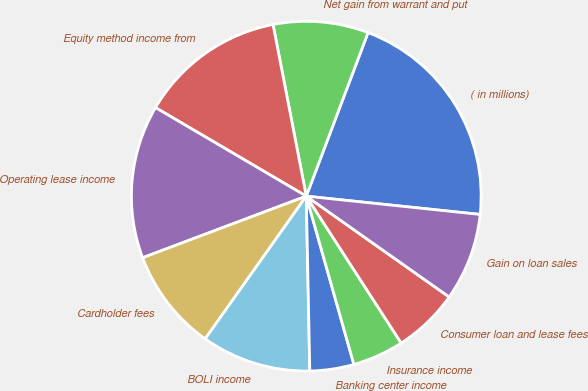Convert chart. <chart><loc_0><loc_0><loc_500><loc_500><pie_chart><fcel>( in millions)<fcel>Net gain from warrant and put<fcel>Equity method income from<fcel>Operating lease income<fcel>Cardholder fees<fcel>BOLI income<fcel>Banking center income<fcel>Insurance income<fcel>Consumer loan and lease fees<fcel>Gain on loan sales<nl><fcel>20.92%<fcel>8.79%<fcel>13.5%<fcel>14.18%<fcel>9.46%<fcel>10.13%<fcel>4.07%<fcel>4.74%<fcel>6.09%<fcel>8.11%<nl></chart> 